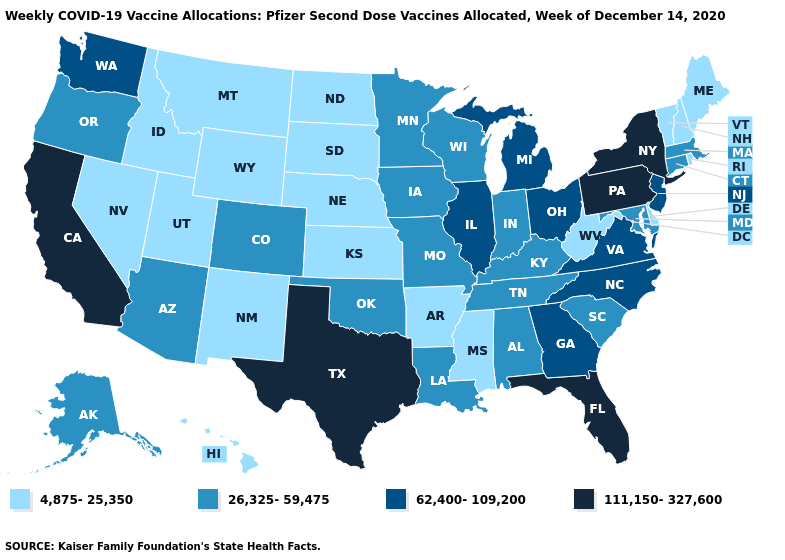How many symbols are there in the legend?
Keep it brief. 4. What is the highest value in states that border Louisiana?
Answer briefly. 111,150-327,600. Which states have the lowest value in the USA?
Quick response, please. Arkansas, Delaware, Hawaii, Idaho, Kansas, Maine, Mississippi, Montana, Nebraska, Nevada, New Hampshire, New Mexico, North Dakota, Rhode Island, South Dakota, Utah, Vermont, West Virginia, Wyoming. What is the value of Pennsylvania?
Write a very short answer. 111,150-327,600. Does California have a higher value than Arkansas?
Keep it brief. Yes. Among the states that border New York , which have the highest value?
Answer briefly. Pennsylvania. How many symbols are there in the legend?
Answer briefly. 4. Name the states that have a value in the range 4,875-25,350?
Write a very short answer. Arkansas, Delaware, Hawaii, Idaho, Kansas, Maine, Mississippi, Montana, Nebraska, Nevada, New Hampshire, New Mexico, North Dakota, Rhode Island, South Dakota, Utah, Vermont, West Virginia, Wyoming. How many symbols are there in the legend?
Write a very short answer. 4. What is the highest value in the MidWest ?
Keep it brief. 62,400-109,200. Name the states that have a value in the range 111,150-327,600?
Write a very short answer. California, Florida, New York, Pennsylvania, Texas. What is the highest value in the USA?
Concise answer only. 111,150-327,600. Name the states that have a value in the range 26,325-59,475?
Give a very brief answer. Alabama, Alaska, Arizona, Colorado, Connecticut, Indiana, Iowa, Kentucky, Louisiana, Maryland, Massachusetts, Minnesota, Missouri, Oklahoma, Oregon, South Carolina, Tennessee, Wisconsin. Name the states that have a value in the range 111,150-327,600?
Short answer required. California, Florida, New York, Pennsylvania, Texas. Which states have the highest value in the USA?
Answer briefly. California, Florida, New York, Pennsylvania, Texas. 